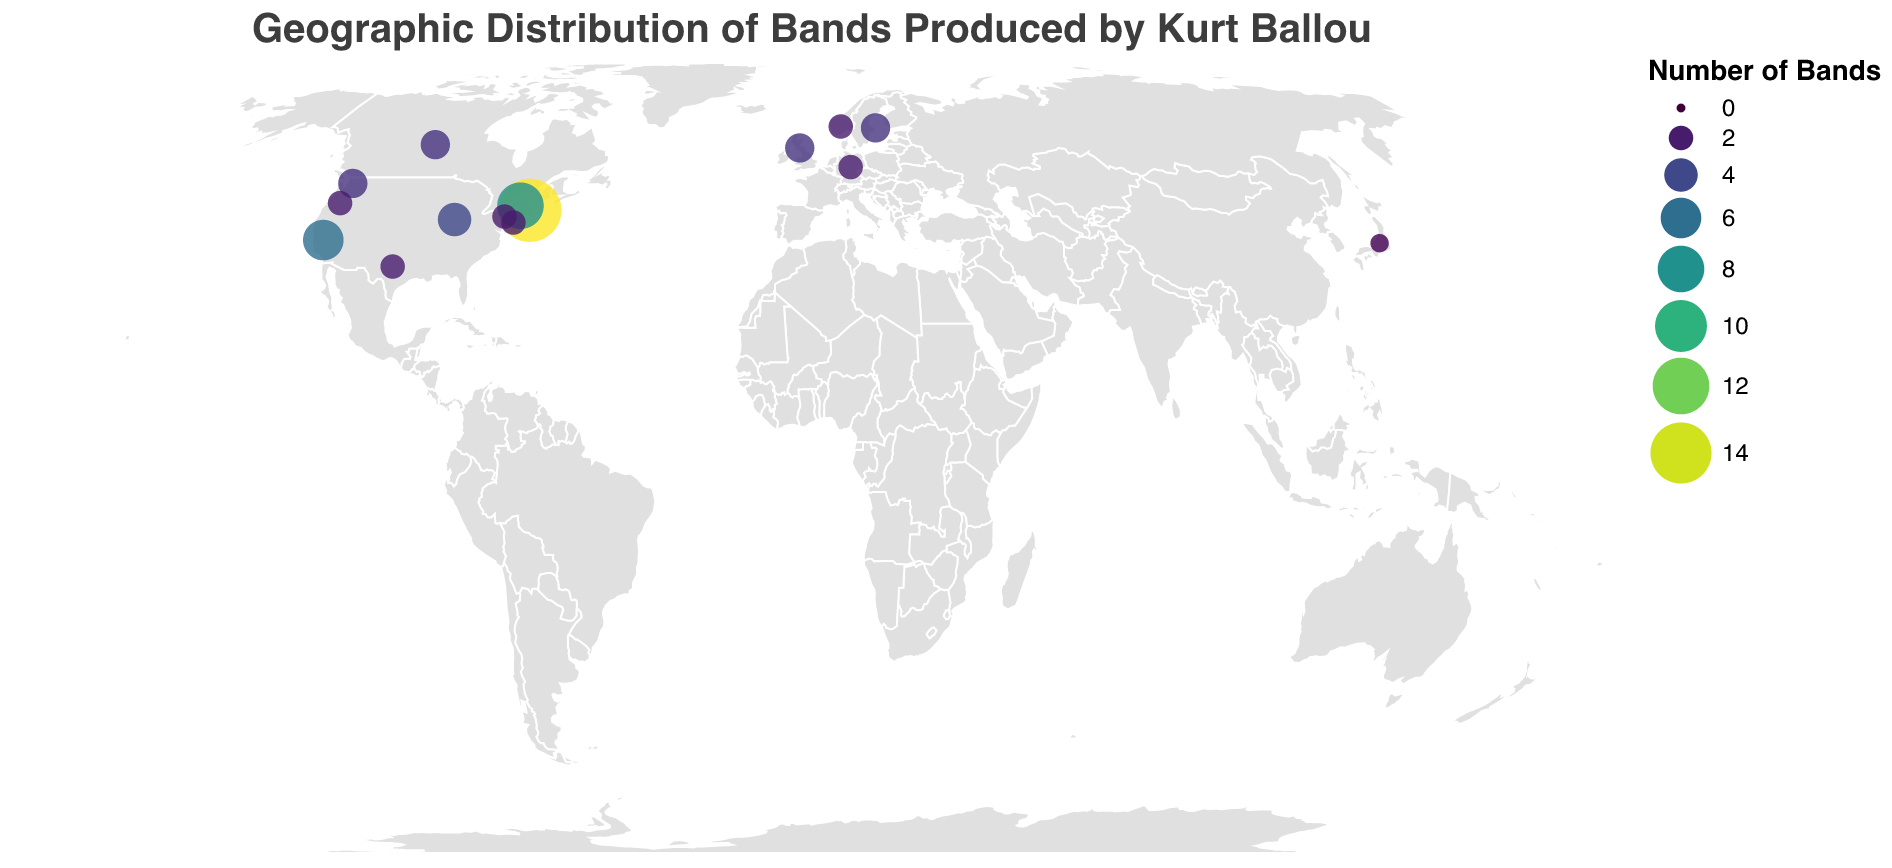What is the title of the figure? The title of the figure is displayed at the top and clearly states what the figure is about.
Answer: Geographic Distribution of Bands Produced by Kurt Ballou How many regions have more than 10 bands produced by Kurt Ballou? Observing the figure, only Massachusetts has more than 10 bands produced by Kurt Ballou, highlighted by the circle size and color intensity.
Answer: 1 Which region has the highest concentration of bands produced by Kurt Ballou? Checking the size of the circles and the tooltip information, Massachusetts has the highest concentration with 15 bands.
Answer: Massachusetts How does the number of bands in California compare to that in New York? By looking at the size of the circles, California has 6 bands while New York has 8 bands produced by Kurt Ballou. This comparison can be confirmed by the tooltips.
Answer: New York has more bands than California What is the total number of bands produced by Kurt Ballou across all regions? Summing up the "Number of Bands" across all listed regions: 15 (MA) + 8 (NY) + 6 (CA) + 4 (IL) + 3 (WA) + 2 (OR) + 2 (TX) + 2 (PA) + 2 (NJ) + 3 (Sweden) + 2 (Norway) + 3 (UK) + 2 (Germany) + 3 (Canada) + 1 (Japan) = 54.
Answer: 54 Which country outside the USA has the highest number of bands produced by Kurt Ballou? Analyzing the international regions, we find that Sweden, the United Kingdom, and Canada each have 3 bands produced by Kurt Ballou.
Answer: Sweden, United Kingdom, Canada What are the coordinates (latitude and longitude) of the region with the highest number of bands produced by Kurt Ballou? Referring to the data, Massachusetts has the highest number with 15 bands, and its coordinates are given in the dataset.
Answer: 42.4072, -71.3824 Which two regions have an equal number of bands produced, and how many bands do they each have? By cross-referencing the similar circle sizes and tooltip data, Oregon and New Jersey both have 2 bands.
Answer: Oregon, New Jersey (2 Bands each) What patterns do you notice in the geographic distribution of bands produced by Kurt Ballou? The figure shows a concentration of bands in the northeastern United States, especially in Massachusetts, followed by noticeable distributions in other parts of the US and several regions in Europe.
Answer: Concentration in the northeastern US, dispersed to Europe Compare the number of bands produced by Kurt Ballou in Washington to those in Pennsylvania. By examining the circle sizes and the tooltip details, Washington has 3 bands while Pennsylvania has 2 bands.
Answer: Washington has more bands than Pennsylvania 